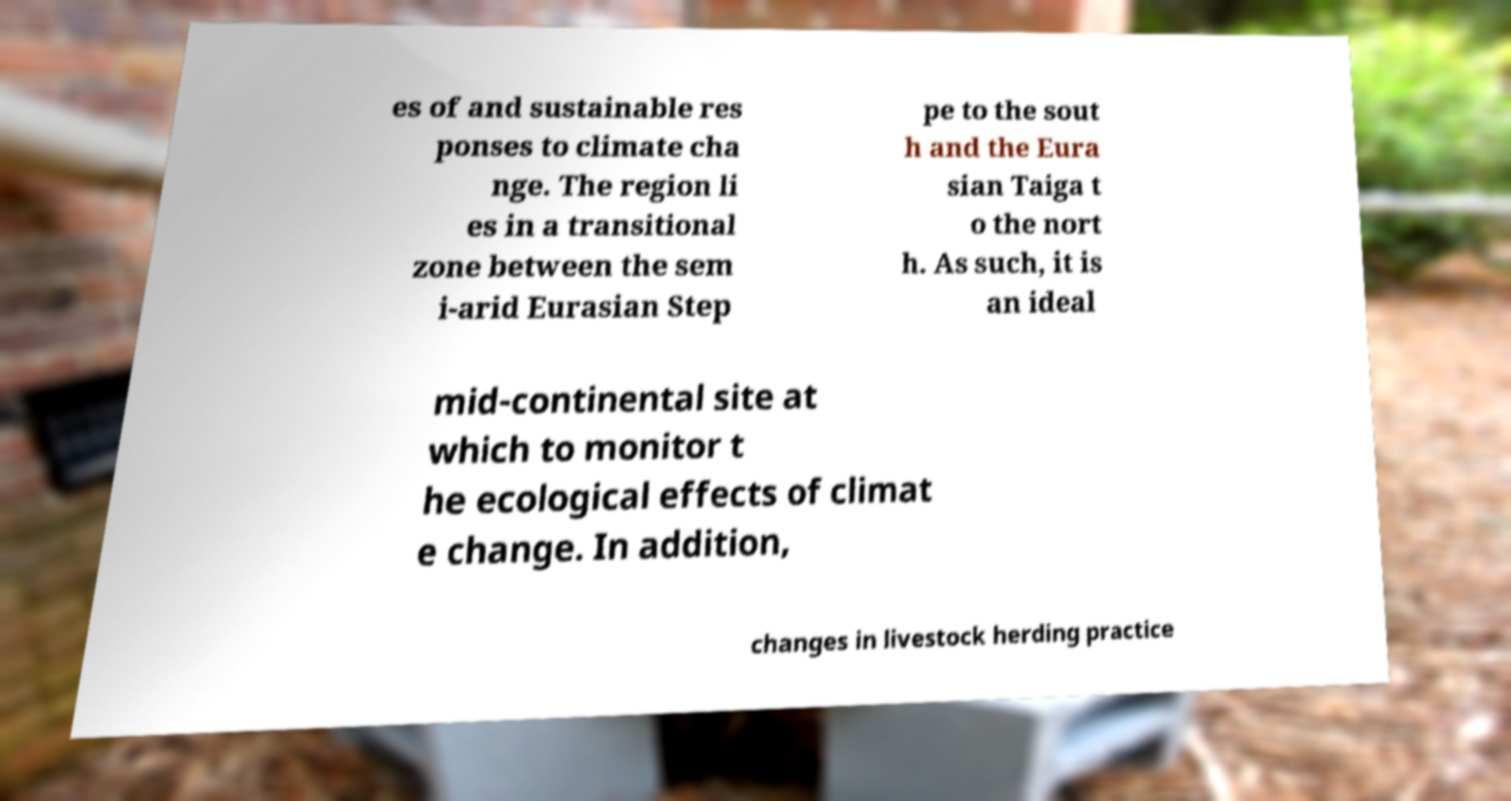Can you accurately transcribe the text from the provided image for me? es of and sustainable res ponses to climate cha nge. The region li es in a transitional zone between the sem i-arid Eurasian Step pe to the sout h and the Eura sian Taiga t o the nort h. As such, it is an ideal mid-continental site at which to monitor t he ecological effects of climat e change. In addition, changes in livestock herding practice 